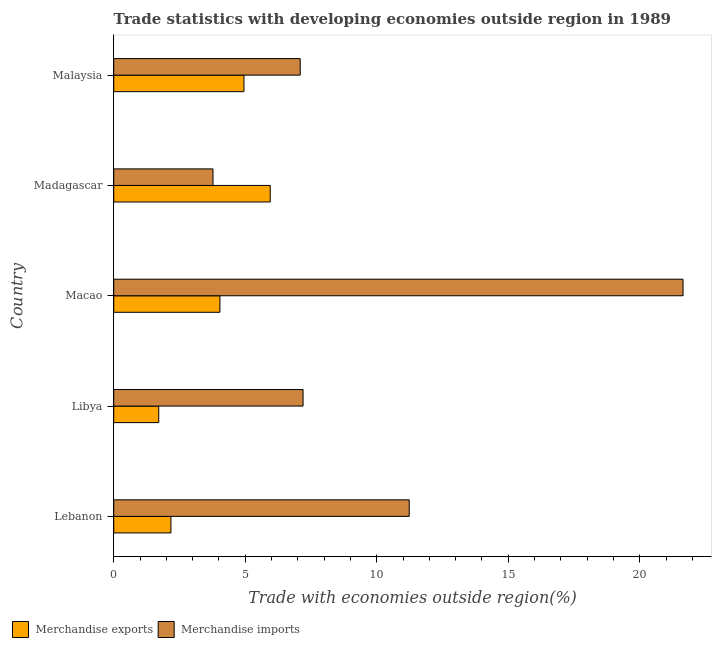How many different coloured bars are there?
Ensure brevity in your answer.  2. Are the number of bars per tick equal to the number of legend labels?
Give a very brief answer. Yes. Are the number of bars on each tick of the Y-axis equal?
Your response must be concise. Yes. How many bars are there on the 5th tick from the top?
Make the answer very short. 2. What is the label of the 4th group of bars from the top?
Offer a terse response. Libya. What is the merchandise imports in Libya?
Provide a succinct answer. 7.2. Across all countries, what is the maximum merchandise imports?
Your response must be concise. 21.65. Across all countries, what is the minimum merchandise imports?
Provide a succinct answer. 3.77. In which country was the merchandise exports maximum?
Keep it short and to the point. Madagascar. In which country was the merchandise exports minimum?
Your answer should be compact. Libya. What is the total merchandise exports in the graph?
Provide a succinct answer. 18.83. What is the difference between the merchandise exports in Lebanon and that in Libya?
Your answer should be very brief. 0.46. What is the difference between the merchandise exports in Libya and the merchandise imports in Lebanon?
Give a very brief answer. -9.52. What is the average merchandise imports per country?
Your response must be concise. 10.19. What is the difference between the merchandise exports and merchandise imports in Madagascar?
Ensure brevity in your answer.  2.18. What is the ratio of the merchandise exports in Libya to that in Madagascar?
Your response must be concise. 0.29. Is the merchandise imports in Macao less than that in Madagascar?
Keep it short and to the point. No. What is the difference between the highest and the lowest merchandise imports?
Your answer should be compact. 17.87. In how many countries, is the merchandise exports greater than the average merchandise exports taken over all countries?
Provide a short and direct response. 3. What does the 2nd bar from the bottom in Lebanon represents?
Provide a short and direct response. Merchandise imports. How many countries are there in the graph?
Offer a terse response. 5. What is the difference between two consecutive major ticks on the X-axis?
Your answer should be compact. 5. Does the graph contain any zero values?
Provide a succinct answer. No. Where does the legend appear in the graph?
Make the answer very short. Bottom left. What is the title of the graph?
Provide a short and direct response. Trade statistics with developing economies outside region in 1989. Does "Merchandise imports" appear as one of the legend labels in the graph?
Ensure brevity in your answer.  Yes. What is the label or title of the X-axis?
Offer a very short reply. Trade with economies outside region(%). What is the Trade with economies outside region(%) in Merchandise exports in Lebanon?
Your answer should be very brief. 2.17. What is the Trade with economies outside region(%) in Merchandise imports in Lebanon?
Ensure brevity in your answer.  11.24. What is the Trade with economies outside region(%) of Merchandise exports in Libya?
Your response must be concise. 1.71. What is the Trade with economies outside region(%) in Merchandise imports in Libya?
Your response must be concise. 7.2. What is the Trade with economies outside region(%) of Merchandise exports in Macao?
Offer a very short reply. 4.04. What is the Trade with economies outside region(%) of Merchandise imports in Macao?
Give a very brief answer. 21.65. What is the Trade with economies outside region(%) in Merchandise exports in Madagascar?
Give a very brief answer. 5.95. What is the Trade with economies outside region(%) of Merchandise imports in Madagascar?
Your response must be concise. 3.77. What is the Trade with economies outside region(%) in Merchandise exports in Malaysia?
Provide a short and direct response. 4.95. What is the Trade with economies outside region(%) in Merchandise imports in Malaysia?
Keep it short and to the point. 7.09. Across all countries, what is the maximum Trade with economies outside region(%) of Merchandise exports?
Keep it short and to the point. 5.95. Across all countries, what is the maximum Trade with economies outside region(%) of Merchandise imports?
Offer a very short reply. 21.65. Across all countries, what is the minimum Trade with economies outside region(%) in Merchandise exports?
Provide a short and direct response. 1.71. Across all countries, what is the minimum Trade with economies outside region(%) of Merchandise imports?
Offer a very short reply. 3.77. What is the total Trade with economies outside region(%) in Merchandise exports in the graph?
Provide a succinct answer. 18.83. What is the total Trade with economies outside region(%) in Merchandise imports in the graph?
Your answer should be compact. 50.95. What is the difference between the Trade with economies outside region(%) in Merchandise exports in Lebanon and that in Libya?
Your answer should be very brief. 0.46. What is the difference between the Trade with economies outside region(%) of Merchandise imports in Lebanon and that in Libya?
Make the answer very short. 4.04. What is the difference between the Trade with economies outside region(%) in Merchandise exports in Lebanon and that in Macao?
Offer a very short reply. -1.86. What is the difference between the Trade with economies outside region(%) of Merchandise imports in Lebanon and that in Macao?
Make the answer very short. -10.41. What is the difference between the Trade with economies outside region(%) of Merchandise exports in Lebanon and that in Madagascar?
Ensure brevity in your answer.  -3.78. What is the difference between the Trade with economies outside region(%) of Merchandise imports in Lebanon and that in Madagascar?
Make the answer very short. 7.46. What is the difference between the Trade with economies outside region(%) of Merchandise exports in Lebanon and that in Malaysia?
Your answer should be very brief. -2.78. What is the difference between the Trade with economies outside region(%) of Merchandise imports in Lebanon and that in Malaysia?
Offer a very short reply. 4.15. What is the difference between the Trade with economies outside region(%) of Merchandise exports in Libya and that in Macao?
Your answer should be compact. -2.33. What is the difference between the Trade with economies outside region(%) of Merchandise imports in Libya and that in Macao?
Keep it short and to the point. -14.45. What is the difference between the Trade with economies outside region(%) of Merchandise exports in Libya and that in Madagascar?
Give a very brief answer. -4.24. What is the difference between the Trade with economies outside region(%) in Merchandise imports in Libya and that in Madagascar?
Your answer should be very brief. 3.42. What is the difference between the Trade with economies outside region(%) in Merchandise exports in Libya and that in Malaysia?
Ensure brevity in your answer.  -3.24. What is the difference between the Trade with economies outside region(%) in Merchandise imports in Libya and that in Malaysia?
Ensure brevity in your answer.  0.11. What is the difference between the Trade with economies outside region(%) of Merchandise exports in Macao and that in Madagascar?
Your answer should be compact. -1.91. What is the difference between the Trade with economies outside region(%) of Merchandise imports in Macao and that in Madagascar?
Offer a terse response. 17.87. What is the difference between the Trade with economies outside region(%) in Merchandise exports in Macao and that in Malaysia?
Your answer should be compact. -0.91. What is the difference between the Trade with economies outside region(%) of Merchandise imports in Macao and that in Malaysia?
Offer a terse response. 14.56. What is the difference between the Trade with economies outside region(%) in Merchandise imports in Madagascar and that in Malaysia?
Provide a succinct answer. -3.32. What is the difference between the Trade with economies outside region(%) of Merchandise exports in Lebanon and the Trade with economies outside region(%) of Merchandise imports in Libya?
Provide a succinct answer. -5.02. What is the difference between the Trade with economies outside region(%) in Merchandise exports in Lebanon and the Trade with economies outside region(%) in Merchandise imports in Macao?
Make the answer very short. -19.47. What is the difference between the Trade with economies outside region(%) in Merchandise exports in Lebanon and the Trade with economies outside region(%) in Merchandise imports in Madagascar?
Make the answer very short. -1.6. What is the difference between the Trade with economies outside region(%) in Merchandise exports in Lebanon and the Trade with economies outside region(%) in Merchandise imports in Malaysia?
Offer a terse response. -4.92. What is the difference between the Trade with economies outside region(%) in Merchandise exports in Libya and the Trade with economies outside region(%) in Merchandise imports in Macao?
Make the answer very short. -19.94. What is the difference between the Trade with economies outside region(%) in Merchandise exports in Libya and the Trade with economies outside region(%) in Merchandise imports in Madagascar?
Provide a succinct answer. -2.06. What is the difference between the Trade with economies outside region(%) in Merchandise exports in Libya and the Trade with economies outside region(%) in Merchandise imports in Malaysia?
Offer a terse response. -5.38. What is the difference between the Trade with economies outside region(%) of Merchandise exports in Macao and the Trade with economies outside region(%) of Merchandise imports in Madagascar?
Your answer should be compact. 0.26. What is the difference between the Trade with economies outside region(%) in Merchandise exports in Macao and the Trade with economies outside region(%) in Merchandise imports in Malaysia?
Provide a short and direct response. -3.05. What is the difference between the Trade with economies outside region(%) in Merchandise exports in Madagascar and the Trade with economies outside region(%) in Merchandise imports in Malaysia?
Your answer should be compact. -1.14. What is the average Trade with economies outside region(%) in Merchandise exports per country?
Offer a terse response. 3.77. What is the average Trade with economies outside region(%) in Merchandise imports per country?
Provide a short and direct response. 10.19. What is the difference between the Trade with economies outside region(%) in Merchandise exports and Trade with economies outside region(%) in Merchandise imports in Lebanon?
Keep it short and to the point. -9.06. What is the difference between the Trade with economies outside region(%) of Merchandise exports and Trade with economies outside region(%) of Merchandise imports in Libya?
Give a very brief answer. -5.49. What is the difference between the Trade with economies outside region(%) in Merchandise exports and Trade with economies outside region(%) in Merchandise imports in Macao?
Offer a terse response. -17.61. What is the difference between the Trade with economies outside region(%) of Merchandise exports and Trade with economies outside region(%) of Merchandise imports in Madagascar?
Your response must be concise. 2.18. What is the difference between the Trade with economies outside region(%) in Merchandise exports and Trade with economies outside region(%) in Merchandise imports in Malaysia?
Your answer should be compact. -2.14. What is the ratio of the Trade with economies outside region(%) of Merchandise exports in Lebanon to that in Libya?
Offer a terse response. 1.27. What is the ratio of the Trade with economies outside region(%) in Merchandise imports in Lebanon to that in Libya?
Your answer should be compact. 1.56. What is the ratio of the Trade with economies outside region(%) of Merchandise exports in Lebanon to that in Macao?
Your answer should be very brief. 0.54. What is the ratio of the Trade with economies outside region(%) of Merchandise imports in Lebanon to that in Macao?
Provide a short and direct response. 0.52. What is the ratio of the Trade with economies outside region(%) of Merchandise exports in Lebanon to that in Madagascar?
Provide a succinct answer. 0.37. What is the ratio of the Trade with economies outside region(%) in Merchandise imports in Lebanon to that in Madagascar?
Ensure brevity in your answer.  2.98. What is the ratio of the Trade with economies outside region(%) of Merchandise exports in Lebanon to that in Malaysia?
Keep it short and to the point. 0.44. What is the ratio of the Trade with economies outside region(%) in Merchandise imports in Lebanon to that in Malaysia?
Offer a terse response. 1.58. What is the ratio of the Trade with economies outside region(%) in Merchandise exports in Libya to that in Macao?
Provide a succinct answer. 0.42. What is the ratio of the Trade with economies outside region(%) in Merchandise imports in Libya to that in Macao?
Your answer should be compact. 0.33. What is the ratio of the Trade with economies outside region(%) in Merchandise exports in Libya to that in Madagascar?
Your answer should be very brief. 0.29. What is the ratio of the Trade with economies outside region(%) of Merchandise imports in Libya to that in Madagascar?
Keep it short and to the point. 1.91. What is the ratio of the Trade with economies outside region(%) in Merchandise exports in Libya to that in Malaysia?
Provide a succinct answer. 0.35. What is the ratio of the Trade with economies outside region(%) of Merchandise imports in Libya to that in Malaysia?
Give a very brief answer. 1.02. What is the ratio of the Trade with economies outside region(%) in Merchandise exports in Macao to that in Madagascar?
Ensure brevity in your answer.  0.68. What is the ratio of the Trade with economies outside region(%) in Merchandise imports in Macao to that in Madagascar?
Make the answer very short. 5.74. What is the ratio of the Trade with economies outside region(%) in Merchandise exports in Macao to that in Malaysia?
Provide a short and direct response. 0.82. What is the ratio of the Trade with economies outside region(%) of Merchandise imports in Macao to that in Malaysia?
Provide a succinct answer. 3.05. What is the ratio of the Trade with economies outside region(%) in Merchandise exports in Madagascar to that in Malaysia?
Ensure brevity in your answer.  1.2. What is the ratio of the Trade with economies outside region(%) of Merchandise imports in Madagascar to that in Malaysia?
Give a very brief answer. 0.53. What is the difference between the highest and the second highest Trade with economies outside region(%) of Merchandise imports?
Offer a terse response. 10.41. What is the difference between the highest and the lowest Trade with economies outside region(%) in Merchandise exports?
Ensure brevity in your answer.  4.24. What is the difference between the highest and the lowest Trade with economies outside region(%) of Merchandise imports?
Keep it short and to the point. 17.87. 